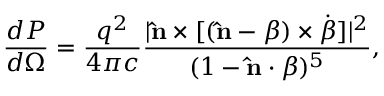Convert formula to latex. <formula><loc_0><loc_0><loc_500><loc_500>{ \frac { d P } { d \Omega } } = { \frac { q ^ { 2 } } { 4 \pi c } } { \frac { | \hat { n } \times [ ( \hat { n } - { \beta } ) \times { \dot { \beta } } ] | ^ { 2 } } { ( 1 - \hat { n } \cdot { \beta } ) ^ { 5 } } } ,</formula> 